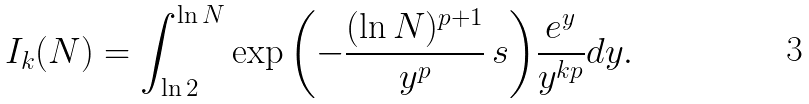Convert formula to latex. <formula><loc_0><loc_0><loc_500><loc_500>I _ { k } ( N ) = \int _ { \ln 2 } ^ { \ln N } \exp { \left ( - \frac { ( \ln N ) ^ { p + 1 } } { y ^ { p } } \, s \right ) } \frac { e ^ { y } } { y ^ { k p } } d y .</formula> 